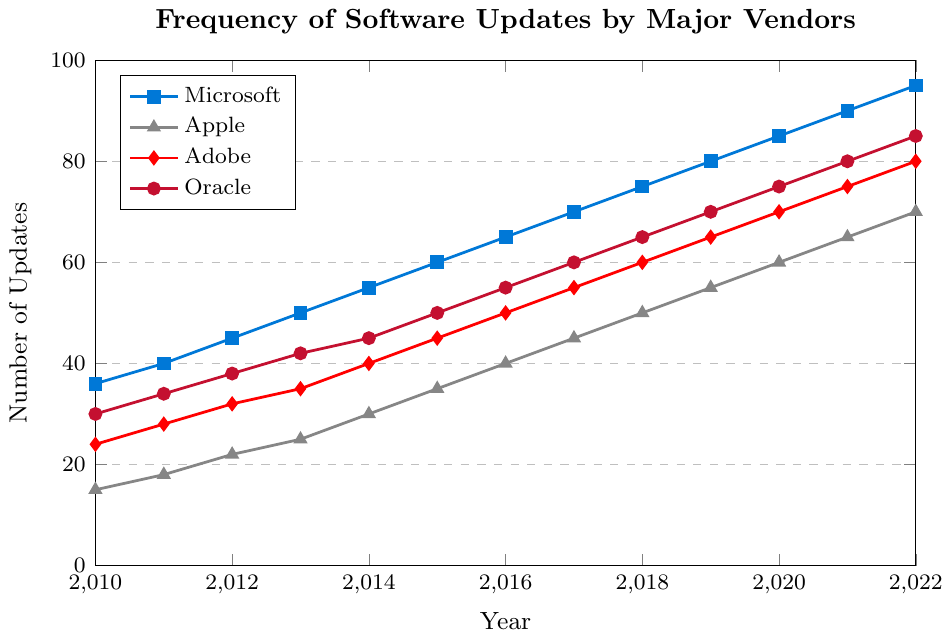How many total updates did Microsoft release from 2010 to 2022? To find the total updates, sum the updates Microsoft released from 2010 to 2022. That is 36 + 40 + 45 + 50 + 55 + 60 + 65 + 70 + 75 + 80 + 85 + 90 + 95. The sum is 846.
Answer: 846 Which vendor had the most updates released in 2022? Look at the year 2022 and compare the number of updates for each vendor. Microsoft has 95, Apple has 70, Adobe has 80, and Oracle has 85. Microsoft has the highest number of updates.
Answer: Microsoft Which vendor showed the most steady increase in updates over the years? A steady increase can be judged by looking at the smoothness and regularity of the line trend. Microsoft has a consistently increasing trend without any fluctuations.
Answer: Microsoft Between 2015 and 2018, which vendor showed the largest increase in updates? Calculate the difference in updates between 2015 and 2018 for each vendor: Microsoft (75 - 60 = 15), Apple (50 - 35 = 15), Adobe (60 - 45 = 15), Oracle (65 - 50 = 15). All vendors had the same increase of 15 updates.
Answer: All vendors How many more updates did Adobe release in 2020 compared to 2010? Subtract the number of updates Adobe released in 2010 from those released in 2020. That is 70 - 24.
Answer: 46 Which vendor released the fewest updates in 2016? Compare the number of updates released by each vendor in 2016: Microsoft (65), Apple (40), Adobe (50), Oracle (55). Apple had the fewest updates.
Answer: Apple From 2010 to 2020, how much more frequent did Microsoft’s updates become? Subtract the number of updates in 2010 from the number in 2020. That is 85 - 36.
Answer: 49 Whose updates increased the least from 2010 to 2022? Calculate the difference for each vendor from 2010 to 2022: Microsoft (95 - 36 = 59), Apple (70 - 15 = 55), Adobe (80 - 24 = 56), Oracle (85 - 30 = 55). Apple and Oracle showed the smallest increase of 55.
Answer: Apple and Oracle What is the average number of updates released by Oracle from 2010 to 2022? To find the average, sum the updates released by Oracle from 2010 to 2022, which is 30 + 34 + 38 + 42 + 45 + 50 + 55 + 60 + 65 + 70 + 75 + 80 + 85 = 729. Divide by the number of years: 729 / 13 = 56.08.
Answer: 56.08 